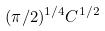Convert formula to latex. <formula><loc_0><loc_0><loc_500><loc_500>( \pi / 2 ) ^ { 1 / 4 } C ^ { 1 / 2 }</formula> 